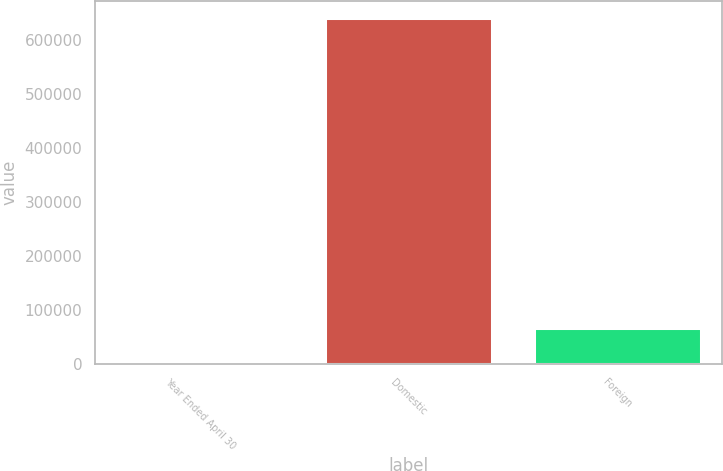Convert chart to OTSL. <chart><loc_0><loc_0><loc_500><loc_500><bar_chart><fcel>Year Ended April 30<fcel>Domestic<fcel>Foreign<nl><fcel>2011<fcel>639914<fcel>65801.3<nl></chart> 